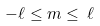<formula> <loc_0><loc_0><loc_500><loc_500>- \ell \leq m \leq \, \ell</formula> 